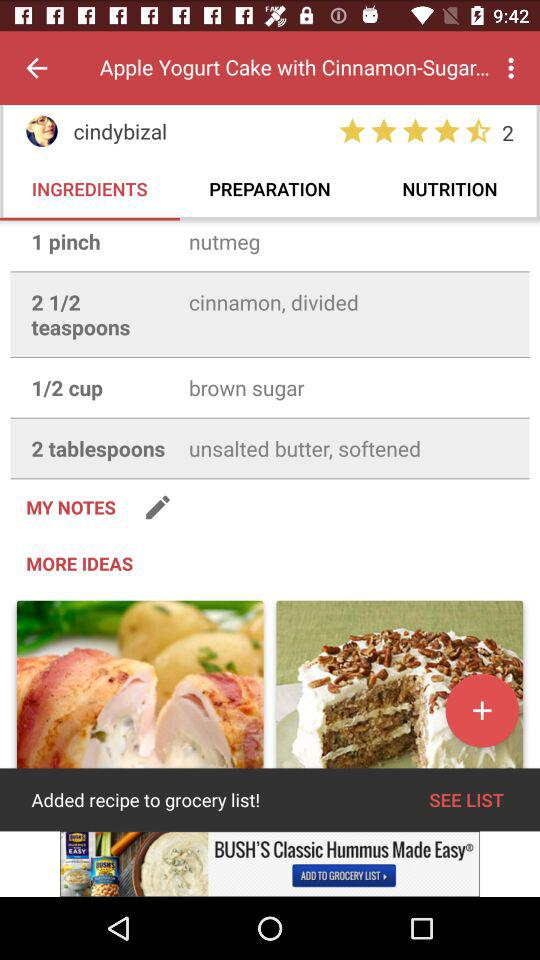How many users have rated? The number of users that have rated is 2. 